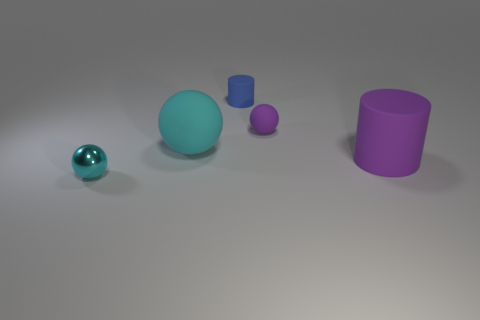What shape is the blue rubber object that is the same size as the metal object?
Your answer should be compact. Cylinder. How many other objects are the same color as the large rubber sphere?
Provide a succinct answer. 1. Is the size of the cyan rubber ball the same as the metallic thing?
Your response must be concise. No. How many things are either small cylinders or small things right of the big cyan ball?
Provide a short and direct response. 2. Is the number of cylinders in front of the small blue cylinder less than the number of cylinders that are to the right of the large cyan matte thing?
Offer a very short reply. Yes. How many other objects are there of the same material as the big purple cylinder?
Provide a short and direct response. 3. Does the matte sphere behind the big sphere have the same color as the big matte cylinder?
Keep it short and to the point. Yes. Is there a big purple thing that is behind the purple matte thing that is in front of the cyan rubber object?
Provide a short and direct response. No. There is a thing that is both left of the tiny blue cylinder and behind the tiny cyan shiny thing; what is it made of?
Give a very brief answer. Rubber. What is the shape of the cyan object that is made of the same material as the blue thing?
Offer a very short reply. Sphere. 